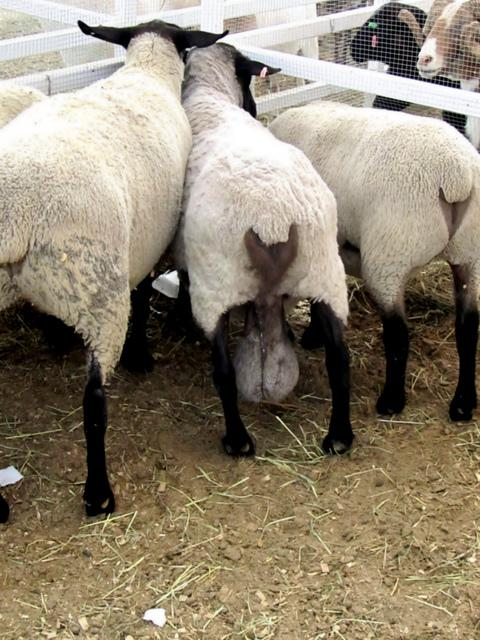What is hanging on the belly of the sheep in the middle?

Choices:
A) bell
B) udder
C) gong
D) saddle udder 